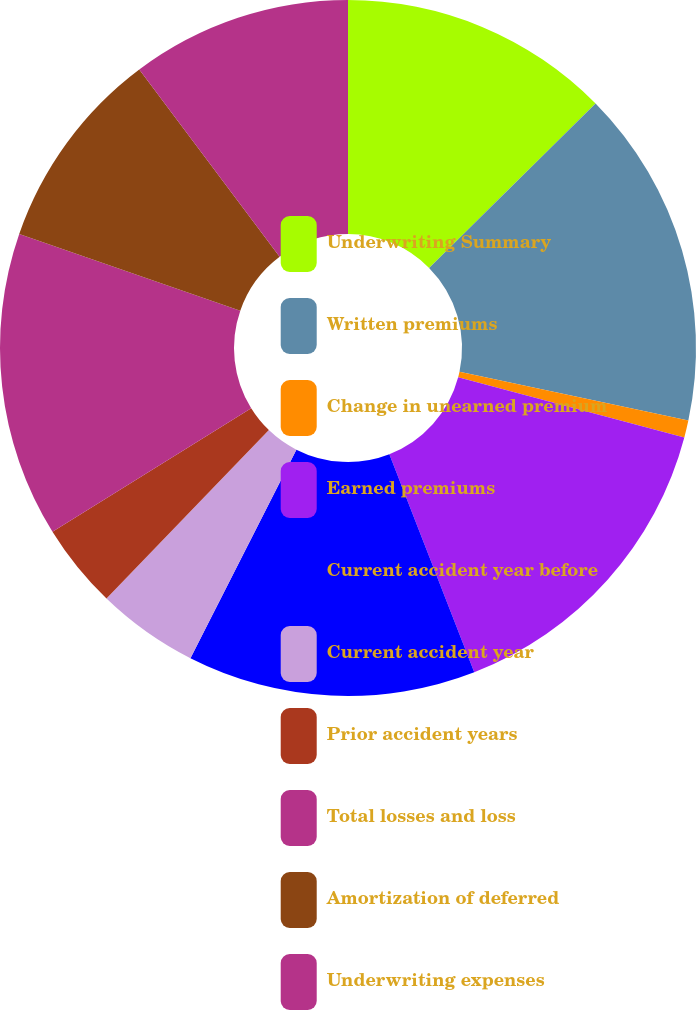<chart> <loc_0><loc_0><loc_500><loc_500><pie_chart><fcel>Underwriting Summary<fcel>Written premiums<fcel>Change in unearned premium<fcel>Earned premiums<fcel>Current accident year before<fcel>Current accident year<fcel>Prior accident years<fcel>Total losses and loss<fcel>Amortization of deferred<fcel>Underwriting expenses<nl><fcel>12.6%<fcel>15.75%<fcel>0.79%<fcel>14.96%<fcel>13.39%<fcel>4.73%<fcel>3.94%<fcel>14.17%<fcel>9.45%<fcel>10.24%<nl></chart> 